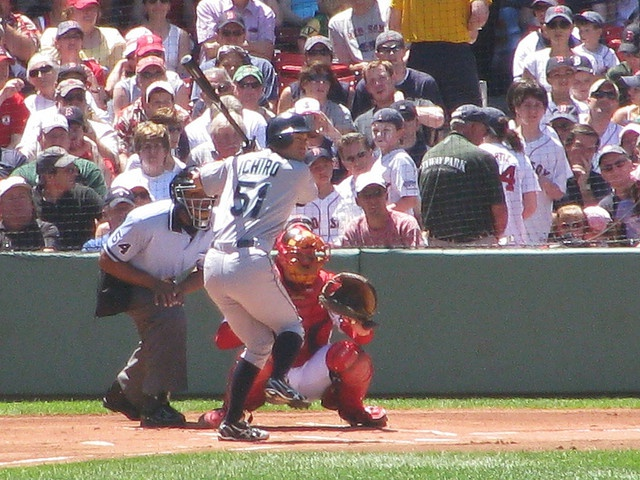Describe the objects in this image and their specific colors. I can see people in brown, gray, white, and darkgray tones, people in brown, gray, and white tones, people in brown, gray, and black tones, people in brown and maroon tones, and people in brown, black, gray, and darkgray tones in this image. 